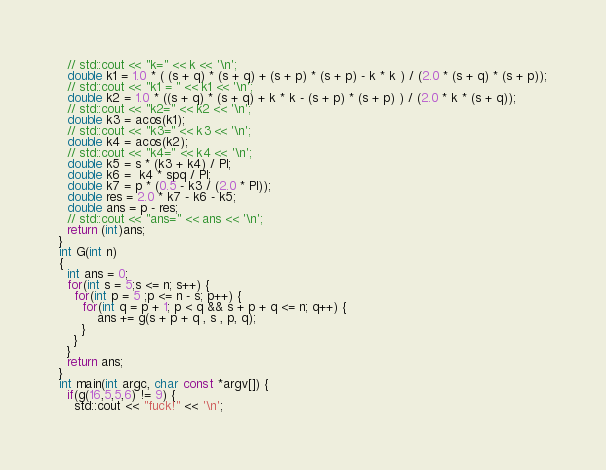<code> <loc_0><loc_0><loc_500><loc_500><_C++_>  // std::cout << "k=" << k << '\n';
  double k1 = 1.0 * ( (s + q) * (s + q) + (s + p) * (s + p) - k * k ) / (2.0 * (s + q) * (s + p));
  // std::cout << "k1 = " << k1 << '\n';
  double k2 = 1.0 * ((s + q) * (s + q) + k * k - (s + p) * (s + p) ) / (2.0 * k * (s + q));
  // std::cout << "k2=" << k2 << '\n';
  double k3 = acos(k1);
  // std::cout << "k3=" << k3 << '\n';
  double k4 = acos(k2);
  // std::cout << "k4=" << k4 << '\n';
  double k5 = s * (k3 + k4) / PI;
  double k6 =  k4 * spq / PI;
  double k7 = p * (0.5 - k3 / (2.0 * PI));
  double res = 2.0 * k7 - k6 - k5;
  double ans = p - res;
  // std::cout << "ans=" << ans << '\n';
  return (int)ans;
}
int G(int n)
{
  int ans = 0;
  for(int s = 5;s <= n; s++) {
    for(int p = 5 ;p <= n - s; p++) {
      for(int q = p + 1; p < q && s + p + q <= n; q++) {
          ans += g(s + p + q , s , p, q);
      }
    }
  }
  return ans;
}
int main(int argc, char const *argv[]) {
  if(g(16,5,5,6) != 9) {
    std::cout << "fuck!" << '\n';</code> 